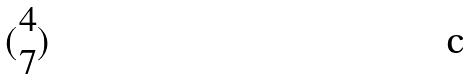<formula> <loc_0><loc_0><loc_500><loc_500>( \begin{matrix} 4 \\ 7 \end{matrix} )</formula> 